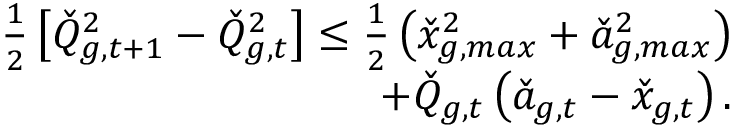<formula> <loc_0><loc_0><loc_500><loc_500>\begin{array} { r } { \frac { 1 } { 2 } \left [ \check { Q } _ { g , t + 1 } ^ { 2 } - \check { Q } _ { g , t } ^ { 2 } \right ] \leq \frac { 1 } { 2 } \left ( \check { x } _ { g , \max } ^ { 2 } + \check { a } _ { g , \max } ^ { 2 } \right ) } \\ { + \check { Q } _ { g , t } \left ( \check { a } _ { g , t } - \check { x } _ { g , t } \right ) . } \end{array}</formula> 